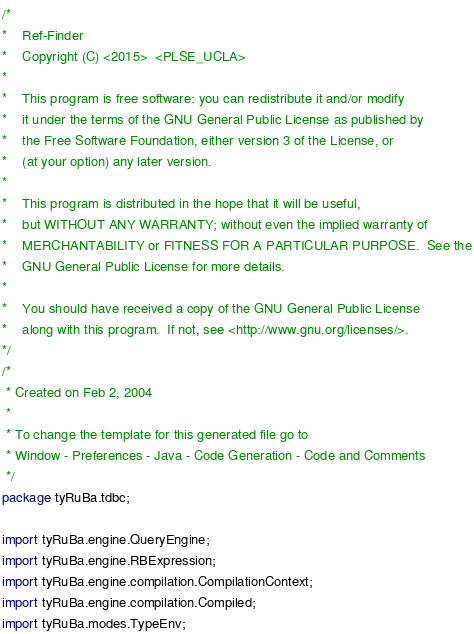Convert code to text. <code><loc_0><loc_0><loc_500><loc_500><_Java_>/* 
*    Ref-Finder
*    Copyright (C) <2015>  <PLSE_UCLA>
*
*    This program is free software: you can redistribute it and/or modify
*    it under the terms of the GNU General Public License as published by
*    the Free Software Foundation, either version 3 of the License, or
*    (at your option) any later version.
*
*    This program is distributed in the hope that it will be useful,
*    but WITHOUT ANY WARRANTY; without even the implied warranty of
*    MERCHANTABILITY or FITNESS FOR A PARTICULAR PURPOSE.  See the
*    GNU General Public License for more details.
*
*    You should have received a copy of the GNU General Public License
*    along with this program.  If not, see <http://www.gnu.org/licenses/>.
*/
/*
 * Created on Feb 2, 2004
 *
 * To change the template for this generated file go to
 * Window - Preferences - Java - Code Generation - Code and Comments
 */
package tyRuBa.tdbc;

import tyRuBa.engine.QueryEngine;
import tyRuBa.engine.RBExpression;
import tyRuBa.engine.compilation.CompilationContext;
import tyRuBa.engine.compilation.Compiled;
import tyRuBa.modes.TypeEnv;</code> 